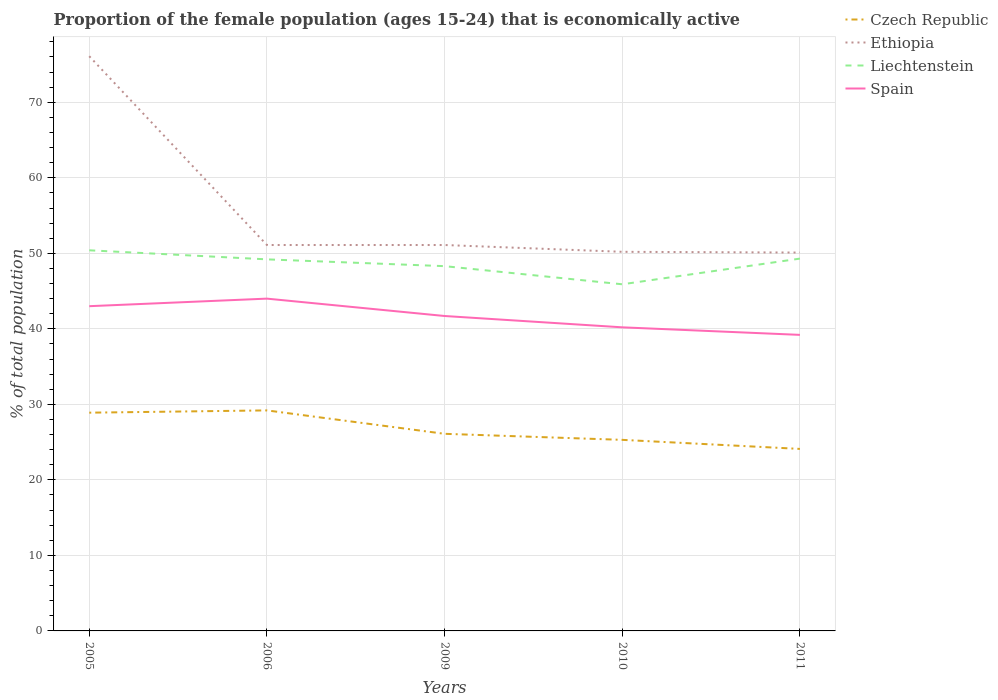How many different coloured lines are there?
Offer a very short reply. 4. Does the line corresponding to Czech Republic intersect with the line corresponding to Ethiopia?
Your response must be concise. No. Is the number of lines equal to the number of legend labels?
Your answer should be compact. Yes. Across all years, what is the maximum proportion of the female population that is economically active in Czech Republic?
Offer a very short reply. 24.1. In which year was the proportion of the female population that is economically active in Spain maximum?
Give a very brief answer. 2011. What is the difference between the highest and the second highest proportion of the female population that is economically active in Czech Republic?
Offer a very short reply. 5.1. What is the difference between the highest and the lowest proportion of the female population that is economically active in Ethiopia?
Make the answer very short. 1. Is the proportion of the female population that is economically active in Spain strictly greater than the proportion of the female population that is economically active in Ethiopia over the years?
Your response must be concise. Yes. How many years are there in the graph?
Make the answer very short. 5. What is the difference between two consecutive major ticks on the Y-axis?
Your response must be concise. 10. Are the values on the major ticks of Y-axis written in scientific E-notation?
Make the answer very short. No. Does the graph contain any zero values?
Ensure brevity in your answer.  No. Does the graph contain grids?
Offer a terse response. Yes. How many legend labels are there?
Offer a terse response. 4. What is the title of the graph?
Give a very brief answer. Proportion of the female population (ages 15-24) that is economically active. Does "Central African Republic" appear as one of the legend labels in the graph?
Provide a short and direct response. No. What is the label or title of the X-axis?
Provide a succinct answer. Years. What is the label or title of the Y-axis?
Your response must be concise. % of total population. What is the % of total population of Czech Republic in 2005?
Offer a very short reply. 28.9. What is the % of total population of Ethiopia in 2005?
Offer a very short reply. 76.1. What is the % of total population of Liechtenstein in 2005?
Your response must be concise. 50.4. What is the % of total population in Czech Republic in 2006?
Offer a very short reply. 29.2. What is the % of total population of Ethiopia in 2006?
Your response must be concise. 51.1. What is the % of total population in Liechtenstein in 2006?
Give a very brief answer. 49.2. What is the % of total population of Spain in 2006?
Give a very brief answer. 44. What is the % of total population in Czech Republic in 2009?
Give a very brief answer. 26.1. What is the % of total population in Ethiopia in 2009?
Make the answer very short. 51.1. What is the % of total population of Liechtenstein in 2009?
Ensure brevity in your answer.  48.3. What is the % of total population in Spain in 2009?
Ensure brevity in your answer.  41.7. What is the % of total population of Czech Republic in 2010?
Offer a very short reply. 25.3. What is the % of total population in Ethiopia in 2010?
Keep it short and to the point. 50.2. What is the % of total population of Liechtenstein in 2010?
Your answer should be compact. 45.9. What is the % of total population of Spain in 2010?
Offer a terse response. 40.2. What is the % of total population of Czech Republic in 2011?
Ensure brevity in your answer.  24.1. What is the % of total population of Ethiopia in 2011?
Provide a short and direct response. 50.1. What is the % of total population of Liechtenstein in 2011?
Your answer should be compact. 49.3. What is the % of total population in Spain in 2011?
Your answer should be very brief. 39.2. Across all years, what is the maximum % of total population of Czech Republic?
Make the answer very short. 29.2. Across all years, what is the maximum % of total population in Ethiopia?
Keep it short and to the point. 76.1. Across all years, what is the maximum % of total population of Liechtenstein?
Make the answer very short. 50.4. Across all years, what is the minimum % of total population in Czech Republic?
Your answer should be compact. 24.1. Across all years, what is the minimum % of total population in Ethiopia?
Provide a succinct answer. 50.1. Across all years, what is the minimum % of total population of Liechtenstein?
Offer a very short reply. 45.9. Across all years, what is the minimum % of total population in Spain?
Offer a terse response. 39.2. What is the total % of total population in Czech Republic in the graph?
Keep it short and to the point. 133.6. What is the total % of total population in Ethiopia in the graph?
Provide a short and direct response. 278.6. What is the total % of total population in Liechtenstein in the graph?
Your answer should be compact. 243.1. What is the total % of total population in Spain in the graph?
Your answer should be compact. 208.1. What is the difference between the % of total population of Czech Republic in 2005 and that in 2006?
Offer a terse response. -0.3. What is the difference between the % of total population in Spain in 2005 and that in 2006?
Your response must be concise. -1. What is the difference between the % of total population of Czech Republic in 2005 and that in 2009?
Offer a very short reply. 2.8. What is the difference between the % of total population of Ethiopia in 2005 and that in 2009?
Offer a very short reply. 25. What is the difference between the % of total population in Liechtenstein in 2005 and that in 2009?
Your response must be concise. 2.1. What is the difference between the % of total population of Spain in 2005 and that in 2009?
Give a very brief answer. 1.3. What is the difference between the % of total population in Ethiopia in 2005 and that in 2010?
Your response must be concise. 25.9. What is the difference between the % of total population in Liechtenstein in 2005 and that in 2010?
Provide a short and direct response. 4.5. What is the difference between the % of total population of Spain in 2005 and that in 2010?
Make the answer very short. 2.8. What is the difference between the % of total population of Ethiopia in 2005 and that in 2011?
Keep it short and to the point. 26. What is the difference between the % of total population of Liechtenstein in 2005 and that in 2011?
Your answer should be compact. 1.1. What is the difference between the % of total population in Ethiopia in 2006 and that in 2009?
Offer a terse response. 0. What is the difference between the % of total population in Spain in 2006 and that in 2009?
Give a very brief answer. 2.3. What is the difference between the % of total population of Liechtenstein in 2006 and that in 2010?
Offer a very short reply. 3.3. What is the difference between the % of total population of Spain in 2006 and that in 2010?
Your response must be concise. 3.8. What is the difference between the % of total population of Czech Republic in 2006 and that in 2011?
Offer a terse response. 5.1. What is the difference between the % of total population in Liechtenstein in 2009 and that in 2010?
Provide a succinct answer. 2.4. What is the difference between the % of total population of Czech Republic in 2009 and that in 2011?
Offer a terse response. 2. What is the difference between the % of total population of Ethiopia in 2009 and that in 2011?
Your answer should be compact. 1. What is the difference between the % of total population of Czech Republic in 2010 and that in 2011?
Offer a terse response. 1.2. What is the difference between the % of total population of Ethiopia in 2010 and that in 2011?
Give a very brief answer. 0.1. What is the difference between the % of total population in Liechtenstein in 2010 and that in 2011?
Provide a succinct answer. -3.4. What is the difference between the % of total population in Czech Republic in 2005 and the % of total population in Ethiopia in 2006?
Keep it short and to the point. -22.2. What is the difference between the % of total population in Czech Republic in 2005 and the % of total population in Liechtenstein in 2006?
Give a very brief answer. -20.3. What is the difference between the % of total population of Czech Republic in 2005 and the % of total population of Spain in 2006?
Keep it short and to the point. -15.1. What is the difference between the % of total population in Ethiopia in 2005 and the % of total population in Liechtenstein in 2006?
Your answer should be compact. 26.9. What is the difference between the % of total population in Ethiopia in 2005 and the % of total population in Spain in 2006?
Ensure brevity in your answer.  32.1. What is the difference between the % of total population in Liechtenstein in 2005 and the % of total population in Spain in 2006?
Your response must be concise. 6.4. What is the difference between the % of total population of Czech Republic in 2005 and the % of total population of Ethiopia in 2009?
Your answer should be compact. -22.2. What is the difference between the % of total population of Czech Republic in 2005 and the % of total population of Liechtenstein in 2009?
Make the answer very short. -19.4. What is the difference between the % of total population of Czech Republic in 2005 and the % of total population of Spain in 2009?
Make the answer very short. -12.8. What is the difference between the % of total population of Ethiopia in 2005 and the % of total population of Liechtenstein in 2009?
Keep it short and to the point. 27.8. What is the difference between the % of total population in Ethiopia in 2005 and the % of total population in Spain in 2009?
Offer a terse response. 34.4. What is the difference between the % of total population of Czech Republic in 2005 and the % of total population of Ethiopia in 2010?
Your response must be concise. -21.3. What is the difference between the % of total population in Czech Republic in 2005 and the % of total population in Spain in 2010?
Offer a terse response. -11.3. What is the difference between the % of total population of Ethiopia in 2005 and the % of total population of Liechtenstein in 2010?
Give a very brief answer. 30.2. What is the difference between the % of total population in Ethiopia in 2005 and the % of total population in Spain in 2010?
Offer a very short reply. 35.9. What is the difference between the % of total population in Liechtenstein in 2005 and the % of total population in Spain in 2010?
Keep it short and to the point. 10.2. What is the difference between the % of total population of Czech Republic in 2005 and the % of total population of Ethiopia in 2011?
Your answer should be compact. -21.2. What is the difference between the % of total population in Czech Republic in 2005 and the % of total population in Liechtenstein in 2011?
Ensure brevity in your answer.  -20.4. What is the difference between the % of total population in Czech Republic in 2005 and the % of total population in Spain in 2011?
Your answer should be compact. -10.3. What is the difference between the % of total population in Ethiopia in 2005 and the % of total population in Liechtenstein in 2011?
Your answer should be very brief. 26.8. What is the difference between the % of total population in Ethiopia in 2005 and the % of total population in Spain in 2011?
Ensure brevity in your answer.  36.9. What is the difference between the % of total population of Liechtenstein in 2005 and the % of total population of Spain in 2011?
Give a very brief answer. 11.2. What is the difference between the % of total population of Czech Republic in 2006 and the % of total population of Ethiopia in 2009?
Provide a succinct answer. -21.9. What is the difference between the % of total population of Czech Republic in 2006 and the % of total population of Liechtenstein in 2009?
Offer a terse response. -19.1. What is the difference between the % of total population in Ethiopia in 2006 and the % of total population in Liechtenstein in 2009?
Provide a succinct answer. 2.8. What is the difference between the % of total population in Czech Republic in 2006 and the % of total population in Ethiopia in 2010?
Your answer should be very brief. -21. What is the difference between the % of total population in Czech Republic in 2006 and the % of total population in Liechtenstein in 2010?
Offer a very short reply. -16.7. What is the difference between the % of total population in Liechtenstein in 2006 and the % of total population in Spain in 2010?
Offer a very short reply. 9. What is the difference between the % of total population of Czech Republic in 2006 and the % of total population of Ethiopia in 2011?
Your response must be concise. -20.9. What is the difference between the % of total population in Czech Republic in 2006 and the % of total population in Liechtenstein in 2011?
Your response must be concise. -20.1. What is the difference between the % of total population in Ethiopia in 2006 and the % of total population in Spain in 2011?
Your answer should be compact. 11.9. What is the difference between the % of total population in Czech Republic in 2009 and the % of total population in Ethiopia in 2010?
Offer a very short reply. -24.1. What is the difference between the % of total population of Czech Republic in 2009 and the % of total population of Liechtenstein in 2010?
Your response must be concise. -19.8. What is the difference between the % of total population in Czech Republic in 2009 and the % of total population in Spain in 2010?
Offer a terse response. -14.1. What is the difference between the % of total population in Ethiopia in 2009 and the % of total population in Spain in 2010?
Offer a very short reply. 10.9. What is the difference between the % of total population in Czech Republic in 2009 and the % of total population in Ethiopia in 2011?
Your answer should be compact. -24. What is the difference between the % of total population in Czech Republic in 2009 and the % of total population in Liechtenstein in 2011?
Ensure brevity in your answer.  -23.2. What is the difference between the % of total population of Ethiopia in 2009 and the % of total population of Liechtenstein in 2011?
Give a very brief answer. 1.8. What is the difference between the % of total population of Liechtenstein in 2009 and the % of total population of Spain in 2011?
Your answer should be compact. 9.1. What is the difference between the % of total population of Czech Republic in 2010 and the % of total population of Ethiopia in 2011?
Offer a very short reply. -24.8. What is the difference between the % of total population in Czech Republic in 2010 and the % of total population in Liechtenstein in 2011?
Offer a very short reply. -24. What is the difference between the % of total population in Ethiopia in 2010 and the % of total population in Liechtenstein in 2011?
Offer a very short reply. 0.9. What is the average % of total population of Czech Republic per year?
Provide a succinct answer. 26.72. What is the average % of total population in Ethiopia per year?
Make the answer very short. 55.72. What is the average % of total population in Liechtenstein per year?
Ensure brevity in your answer.  48.62. What is the average % of total population of Spain per year?
Your response must be concise. 41.62. In the year 2005, what is the difference between the % of total population in Czech Republic and % of total population in Ethiopia?
Ensure brevity in your answer.  -47.2. In the year 2005, what is the difference between the % of total population in Czech Republic and % of total population in Liechtenstein?
Keep it short and to the point. -21.5. In the year 2005, what is the difference between the % of total population in Czech Republic and % of total population in Spain?
Provide a short and direct response. -14.1. In the year 2005, what is the difference between the % of total population in Ethiopia and % of total population in Liechtenstein?
Provide a succinct answer. 25.7. In the year 2005, what is the difference between the % of total population of Ethiopia and % of total population of Spain?
Your response must be concise. 33.1. In the year 2005, what is the difference between the % of total population of Liechtenstein and % of total population of Spain?
Your answer should be very brief. 7.4. In the year 2006, what is the difference between the % of total population in Czech Republic and % of total population in Ethiopia?
Your answer should be compact. -21.9. In the year 2006, what is the difference between the % of total population in Czech Republic and % of total population in Spain?
Keep it short and to the point. -14.8. In the year 2006, what is the difference between the % of total population in Ethiopia and % of total population in Liechtenstein?
Your answer should be compact. 1.9. In the year 2006, what is the difference between the % of total population of Ethiopia and % of total population of Spain?
Your answer should be compact. 7.1. In the year 2006, what is the difference between the % of total population in Liechtenstein and % of total population in Spain?
Provide a short and direct response. 5.2. In the year 2009, what is the difference between the % of total population of Czech Republic and % of total population of Liechtenstein?
Provide a succinct answer. -22.2. In the year 2009, what is the difference between the % of total population of Czech Republic and % of total population of Spain?
Offer a terse response. -15.6. In the year 2010, what is the difference between the % of total population in Czech Republic and % of total population in Ethiopia?
Make the answer very short. -24.9. In the year 2010, what is the difference between the % of total population of Czech Republic and % of total population of Liechtenstein?
Keep it short and to the point. -20.6. In the year 2010, what is the difference between the % of total population of Czech Republic and % of total population of Spain?
Your response must be concise. -14.9. In the year 2010, what is the difference between the % of total population in Ethiopia and % of total population in Spain?
Ensure brevity in your answer.  10. In the year 2011, what is the difference between the % of total population in Czech Republic and % of total population in Ethiopia?
Make the answer very short. -26. In the year 2011, what is the difference between the % of total population in Czech Republic and % of total population in Liechtenstein?
Provide a succinct answer. -25.2. In the year 2011, what is the difference between the % of total population in Czech Republic and % of total population in Spain?
Offer a very short reply. -15.1. What is the ratio of the % of total population of Czech Republic in 2005 to that in 2006?
Your answer should be very brief. 0.99. What is the ratio of the % of total population in Ethiopia in 2005 to that in 2006?
Ensure brevity in your answer.  1.49. What is the ratio of the % of total population in Liechtenstein in 2005 to that in 2006?
Offer a terse response. 1.02. What is the ratio of the % of total population of Spain in 2005 to that in 2006?
Your answer should be compact. 0.98. What is the ratio of the % of total population of Czech Republic in 2005 to that in 2009?
Offer a terse response. 1.11. What is the ratio of the % of total population of Ethiopia in 2005 to that in 2009?
Your answer should be very brief. 1.49. What is the ratio of the % of total population in Liechtenstein in 2005 to that in 2009?
Keep it short and to the point. 1.04. What is the ratio of the % of total population of Spain in 2005 to that in 2009?
Provide a succinct answer. 1.03. What is the ratio of the % of total population in Czech Republic in 2005 to that in 2010?
Your response must be concise. 1.14. What is the ratio of the % of total population of Ethiopia in 2005 to that in 2010?
Keep it short and to the point. 1.52. What is the ratio of the % of total population of Liechtenstein in 2005 to that in 2010?
Give a very brief answer. 1.1. What is the ratio of the % of total population in Spain in 2005 to that in 2010?
Your answer should be very brief. 1.07. What is the ratio of the % of total population of Czech Republic in 2005 to that in 2011?
Your answer should be compact. 1.2. What is the ratio of the % of total population in Ethiopia in 2005 to that in 2011?
Your answer should be very brief. 1.52. What is the ratio of the % of total population of Liechtenstein in 2005 to that in 2011?
Make the answer very short. 1.02. What is the ratio of the % of total population in Spain in 2005 to that in 2011?
Your response must be concise. 1.1. What is the ratio of the % of total population in Czech Republic in 2006 to that in 2009?
Provide a short and direct response. 1.12. What is the ratio of the % of total population in Liechtenstein in 2006 to that in 2009?
Offer a terse response. 1.02. What is the ratio of the % of total population of Spain in 2006 to that in 2009?
Your response must be concise. 1.06. What is the ratio of the % of total population in Czech Republic in 2006 to that in 2010?
Your response must be concise. 1.15. What is the ratio of the % of total population in Ethiopia in 2006 to that in 2010?
Make the answer very short. 1.02. What is the ratio of the % of total population in Liechtenstein in 2006 to that in 2010?
Offer a terse response. 1.07. What is the ratio of the % of total population in Spain in 2006 to that in 2010?
Give a very brief answer. 1.09. What is the ratio of the % of total population of Czech Republic in 2006 to that in 2011?
Ensure brevity in your answer.  1.21. What is the ratio of the % of total population in Liechtenstein in 2006 to that in 2011?
Make the answer very short. 1. What is the ratio of the % of total population in Spain in 2006 to that in 2011?
Keep it short and to the point. 1.12. What is the ratio of the % of total population in Czech Republic in 2009 to that in 2010?
Your answer should be compact. 1.03. What is the ratio of the % of total population of Ethiopia in 2009 to that in 2010?
Provide a succinct answer. 1.02. What is the ratio of the % of total population in Liechtenstein in 2009 to that in 2010?
Provide a short and direct response. 1.05. What is the ratio of the % of total population of Spain in 2009 to that in 2010?
Your answer should be very brief. 1.04. What is the ratio of the % of total population in Czech Republic in 2009 to that in 2011?
Offer a terse response. 1.08. What is the ratio of the % of total population in Liechtenstein in 2009 to that in 2011?
Give a very brief answer. 0.98. What is the ratio of the % of total population of Spain in 2009 to that in 2011?
Your answer should be very brief. 1.06. What is the ratio of the % of total population of Czech Republic in 2010 to that in 2011?
Provide a short and direct response. 1.05. What is the ratio of the % of total population of Ethiopia in 2010 to that in 2011?
Offer a terse response. 1. What is the ratio of the % of total population in Liechtenstein in 2010 to that in 2011?
Give a very brief answer. 0.93. What is the ratio of the % of total population in Spain in 2010 to that in 2011?
Your answer should be very brief. 1.03. What is the difference between the highest and the second highest % of total population of Ethiopia?
Your response must be concise. 25. What is the difference between the highest and the lowest % of total population in Czech Republic?
Give a very brief answer. 5.1. What is the difference between the highest and the lowest % of total population in Ethiopia?
Make the answer very short. 26. What is the difference between the highest and the lowest % of total population of Spain?
Make the answer very short. 4.8. 